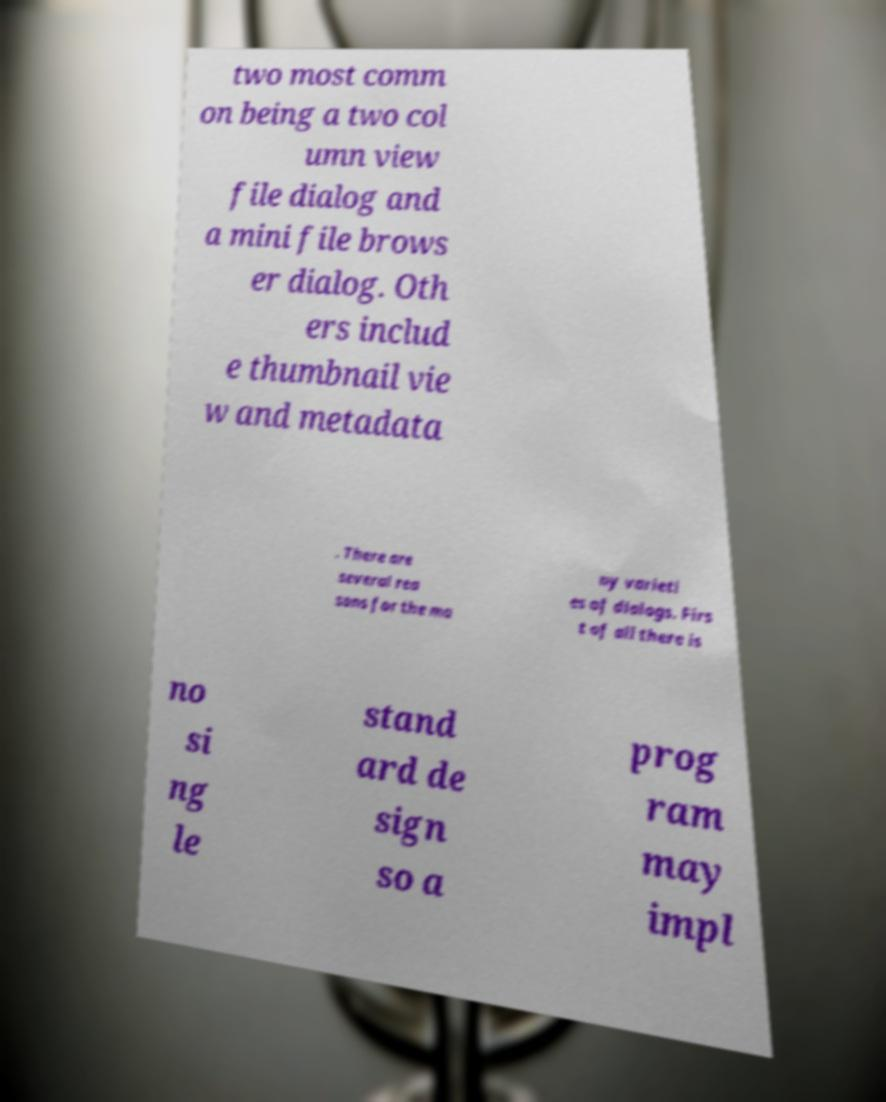Please identify and transcribe the text found in this image. two most comm on being a two col umn view file dialog and a mini file brows er dialog. Oth ers includ e thumbnail vie w and metadata . There are several rea sons for the ma ny varieti es of dialogs. Firs t of all there is no si ng le stand ard de sign so a prog ram may impl 